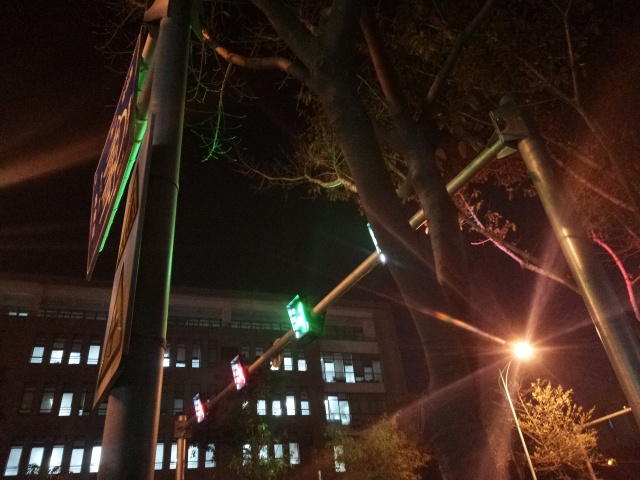What does this photo capture? The photo captures a traffic light showing a red light and a green left arrow, affixed to a post at night. In the background, there's the faintly illuminated facade of a multi-story building with several windows, and the silhouette of a tree intertwines with the urban elements, adding a touch of nature to the scene. 